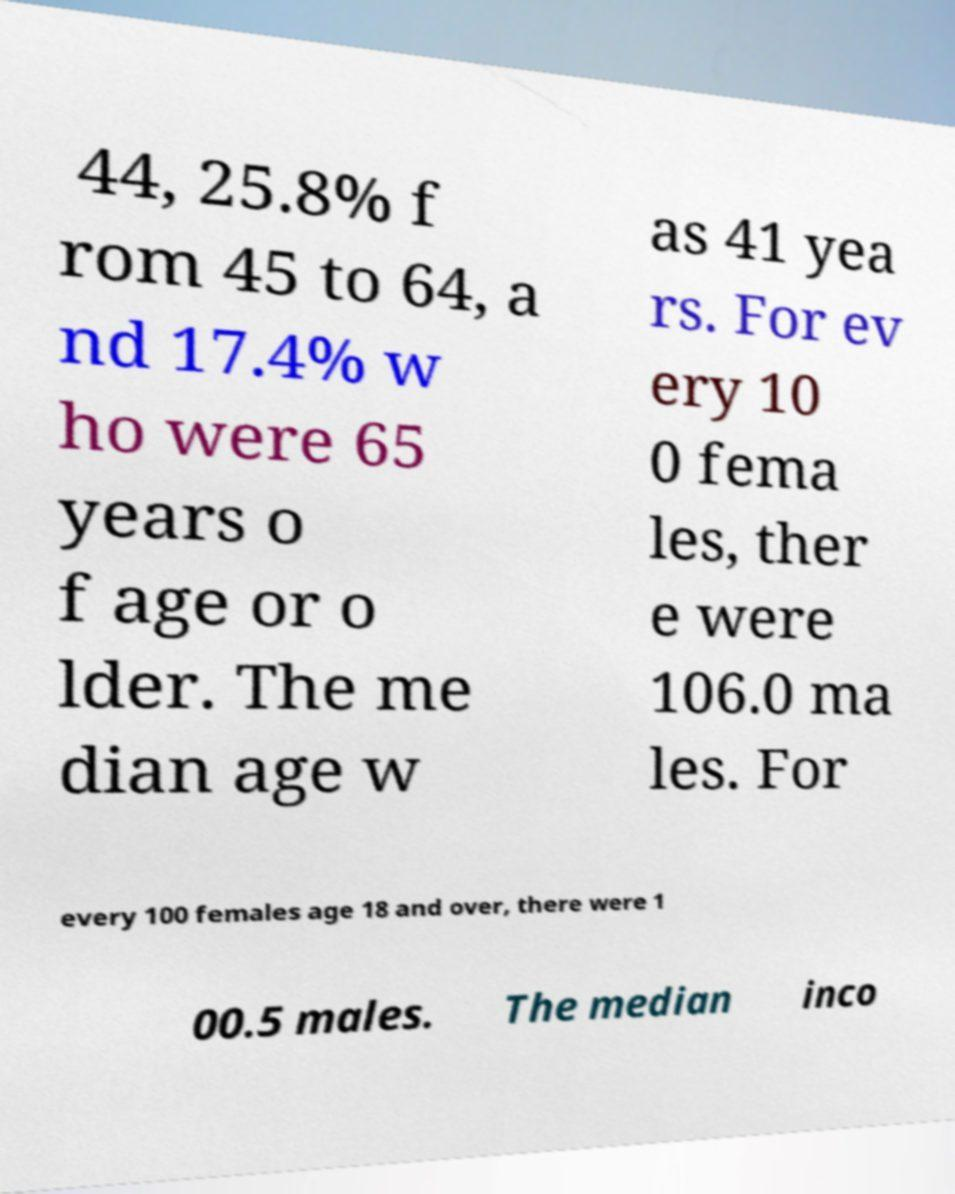What messages or text are displayed in this image? I need them in a readable, typed format. 44, 25.8% f rom 45 to 64, a nd 17.4% w ho were 65 years o f age or o lder. The me dian age w as 41 yea rs. For ev ery 10 0 fema les, ther e were 106.0 ma les. For every 100 females age 18 and over, there were 1 00.5 males. The median inco 